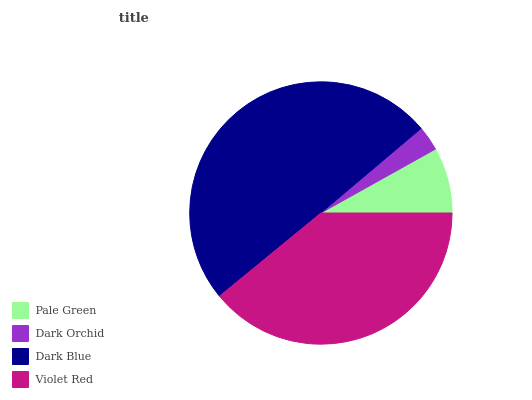Is Dark Orchid the minimum?
Answer yes or no. Yes. Is Dark Blue the maximum?
Answer yes or no. Yes. Is Dark Blue the minimum?
Answer yes or no. No. Is Dark Orchid the maximum?
Answer yes or no. No. Is Dark Blue greater than Dark Orchid?
Answer yes or no. Yes. Is Dark Orchid less than Dark Blue?
Answer yes or no. Yes. Is Dark Orchid greater than Dark Blue?
Answer yes or no. No. Is Dark Blue less than Dark Orchid?
Answer yes or no. No. Is Violet Red the high median?
Answer yes or no. Yes. Is Pale Green the low median?
Answer yes or no. Yes. Is Pale Green the high median?
Answer yes or no. No. Is Violet Red the low median?
Answer yes or no. No. 